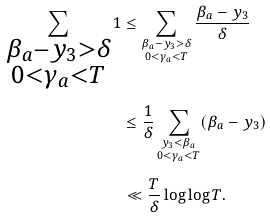Convert formula to latex. <formula><loc_0><loc_0><loc_500><loc_500>\sum _ { \substack { \beta _ { a } - y _ { 3 } > \delta \\ 0 < \gamma _ { a } < T } } 1 & \leq \sum _ { \substack { \beta _ { a } - y _ { 3 } > \delta \\ 0 < \gamma _ { a } < T } } \frac { \beta _ { a } - y _ { 3 } } { \delta } \\ & \leq \frac { 1 } { \delta } \sum _ { \substack { y _ { 3 } < \beta _ { a } \\ 0 < \gamma _ { a } < T } } ( \beta _ { a } - y _ { 3 } ) \\ & \ll \frac { T } { \delta } \log \log T .</formula> 